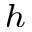Convert formula to latex. <formula><loc_0><loc_0><loc_500><loc_500>^ { h }</formula> 